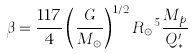Convert formula to latex. <formula><loc_0><loc_0><loc_500><loc_500>\beta = \frac { 1 1 7 } { 4 } \left ( \frac { G } { M _ { \odot } } \right ) ^ { 1 / 2 } { R _ { \odot } } ^ { 5 } \frac { M _ { p } } { Q ^ { \prime } _ { * } }</formula> 